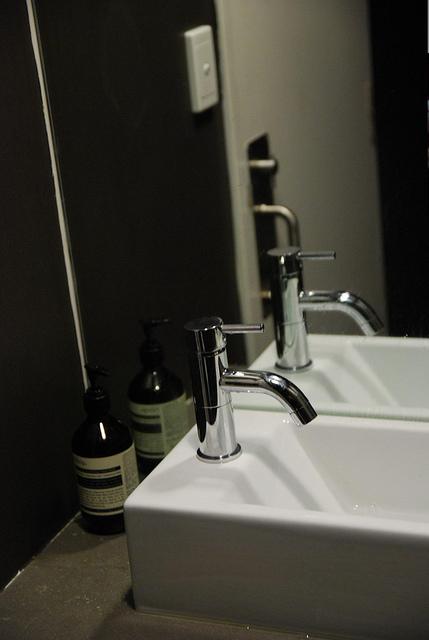Are all the handles on the bathroom sinks the same?
Quick response, please. Yes. What is the shiny silver object in the picture?
Be succinct. Faucet. What does the sink have?
Be succinct. Nothing. What is behind the faucet?
Short answer required. Mirror. 